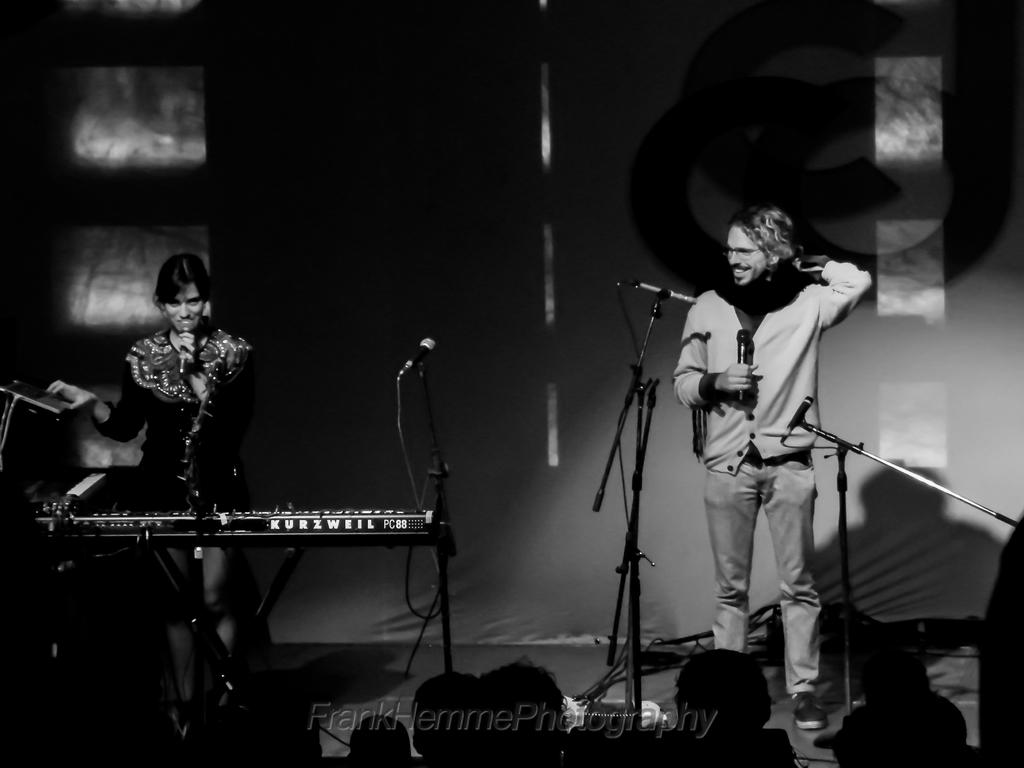What is the color scheme of the image? The image is black and white. How many people are in the image? There are two persons in the image. What are the persons holding in the image? The persons are holding microphones. What is the facial expression of the persons in the image? The persons are smiling. What objects are present in the image besides the persons? There are microphones and a piano present in the image. What is the lighting condition in the image? The background of the image is dark. What type of cover is draped over the piano in the image? There is no cover present on the piano in the image. What is the angle of the slope in the image? There is no slope present in the image. 